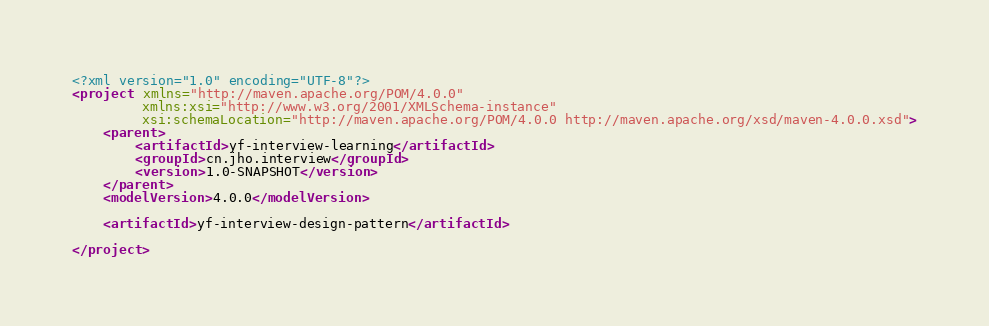Convert code to text. <code><loc_0><loc_0><loc_500><loc_500><_XML_><?xml version="1.0" encoding="UTF-8"?>
<project xmlns="http://maven.apache.org/POM/4.0.0"
         xmlns:xsi="http://www.w3.org/2001/XMLSchema-instance"
         xsi:schemaLocation="http://maven.apache.org/POM/4.0.0 http://maven.apache.org/xsd/maven-4.0.0.xsd">
    <parent>
        <artifactId>yf-interview-learning</artifactId>
        <groupId>cn.jho.interview</groupId>
        <version>1.0-SNAPSHOT</version>
    </parent>
    <modelVersion>4.0.0</modelVersion>

    <artifactId>yf-interview-design-pattern</artifactId>

</project></code> 